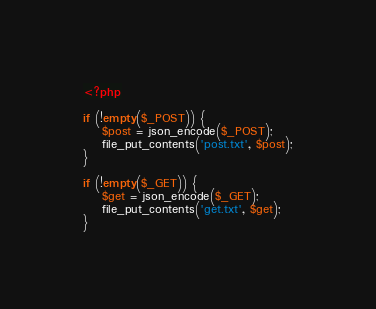<code> <loc_0><loc_0><loc_500><loc_500><_PHP_><?php

if (!empty($_POST)) {
    $post = json_encode($_POST);
    file_put_contents('post.txt', $post);
}

if (!empty($_GET)) {
    $get = json_encode($_GET);
    file_put_contents('get.txt', $get);
}
</code> 